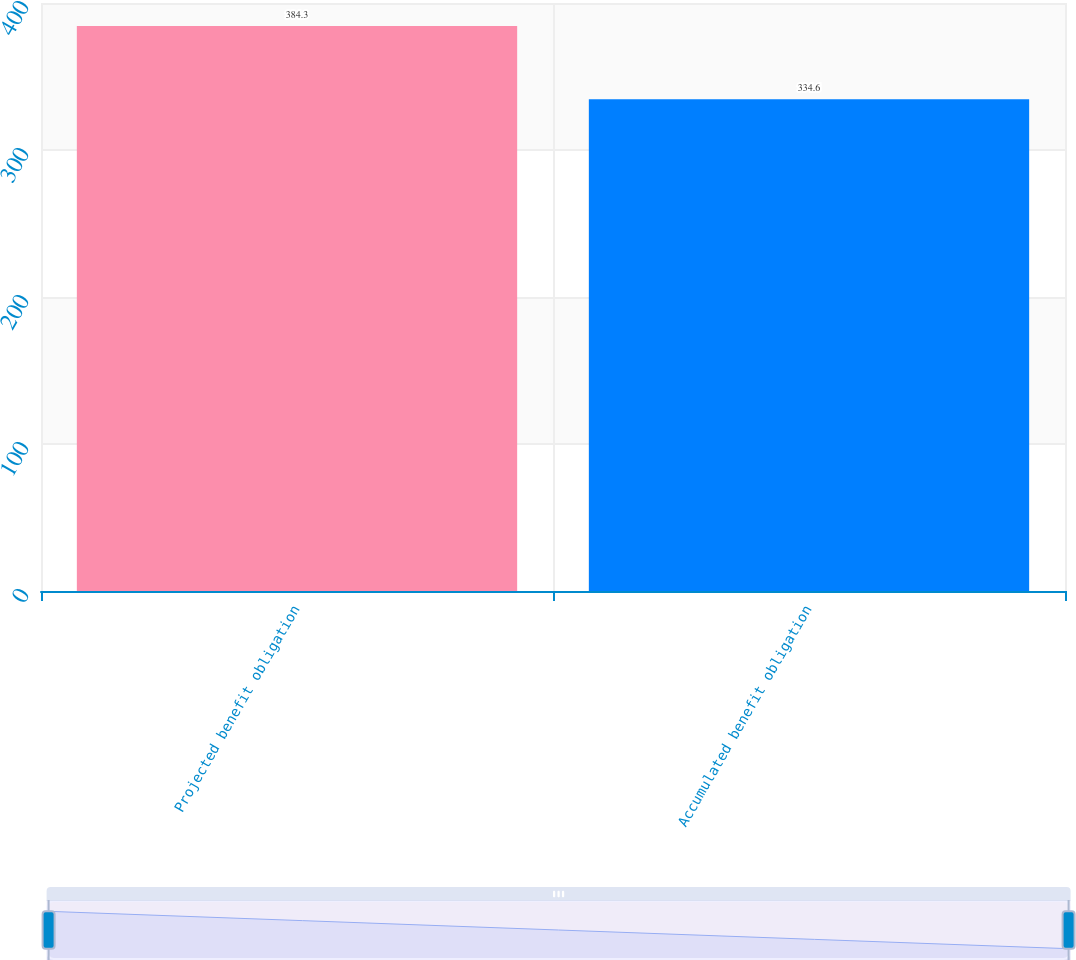Convert chart to OTSL. <chart><loc_0><loc_0><loc_500><loc_500><bar_chart><fcel>Projected benefit obligation<fcel>Accumulated benefit obligation<nl><fcel>384.3<fcel>334.6<nl></chart> 